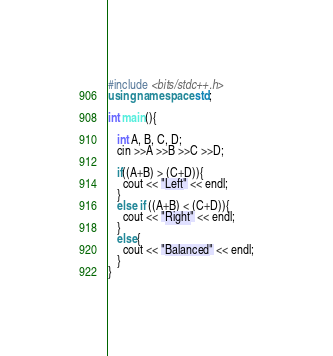<code> <loc_0><loc_0><loc_500><loc_500><_C++_>#include <bits/stdc++.h>
using namespace std;

int main(){

   int A, B, C, D;
   cin >>A >>B >>C >>D;
  
   if((A+B) > (C+D)){
     cout << "Left" << endl;
   }
   else if ((A+B) < (C+D)){
     cout << "Right" << endl;
   }
   else{
     cout << "Balanced" << endl;
   }
}</code> 